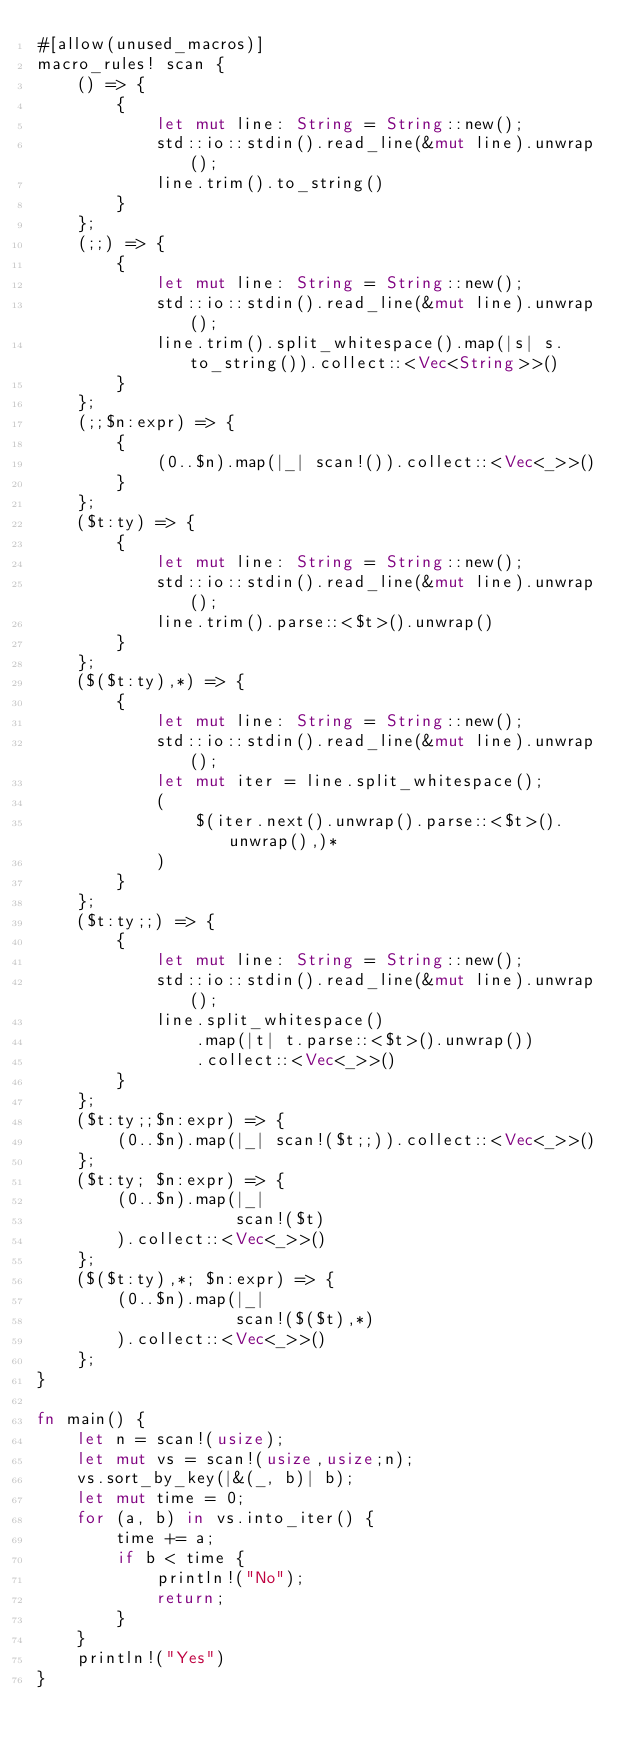<code> <loc_0><loc_0><loc_500><loc_500><_Rust_>#[allow(unused_macros)]
macro_rules! scan {
    () => {
        {
            let mut line: String = String::new();
            std::io::stdin().read_line(&mut line).unwrap();
            line.trim().to_string()
        }
    };
    (;;) => {
        {
            let mut line: String = String::new();
            std::io::stdin().read_line(&mut line).unwrap();
            line.trim().split_whitespace().map(|s| s.to_string()).collect::<Vec<String>>()
        }
    };
    (;;$n:expr) => {
        {
            (0..$n).map(|_| scan!()).collect::<Vec<_>>()
        }
    };
    ($t:ty) => {
        {
            let mut line: String = String::new();
            std::io::stdin().read_line(&mut line).unwrap();
            line.trim().parse::<$t>().unwrap()
        }
    };
    ($($t:ty),*) => {
        {
            let mut line: String = String::new();
            std::io::stdin().read_line(&mut line).unwrap();
            let mut iter = line.split_whitespace();
            (
                $(iter.next().unwrap().parse::<$t>().unwrap(),)*
            )
        }
    };
    ($t:ty;;) => {
        {
            let mut line: String = String::new();
            std::io::stdin().read_line(&mut line).unwrap();
            line.split_whitespace()
                .map(|t| t.parse::<$t>().unwrap())
                .collect::<Vec<_>>()
        }
    };
    ($t:ty;;$n:expr) => {
        (0..$n).map(|_| scan!($t;;)).collect::<Vec<_>>()
    };
    ($t:ty; $n:expr) => {
        (0..$n).map(|_|
                    scan!($t)
        ).collect::<Vec<_>>()
    };
    ($($t:ty),*; $n:expr) => {
        (0..$n).map(|_|
                    scan!($($t),*)
        ).collect::<Vec<_>>()
    };
}

fn main() {
    let n = scan!(usize);
    let mut vs = scan!(usize,usize;n);
    vs.sort_by_key(|&(_, b)| b);
    let mut time = 0;
    for (a, b) in vs.into_iter() {
        time += a;
        if b < time {
            println!("No");
            return;
        }
    }
    println!("Yes")
}
</code> 